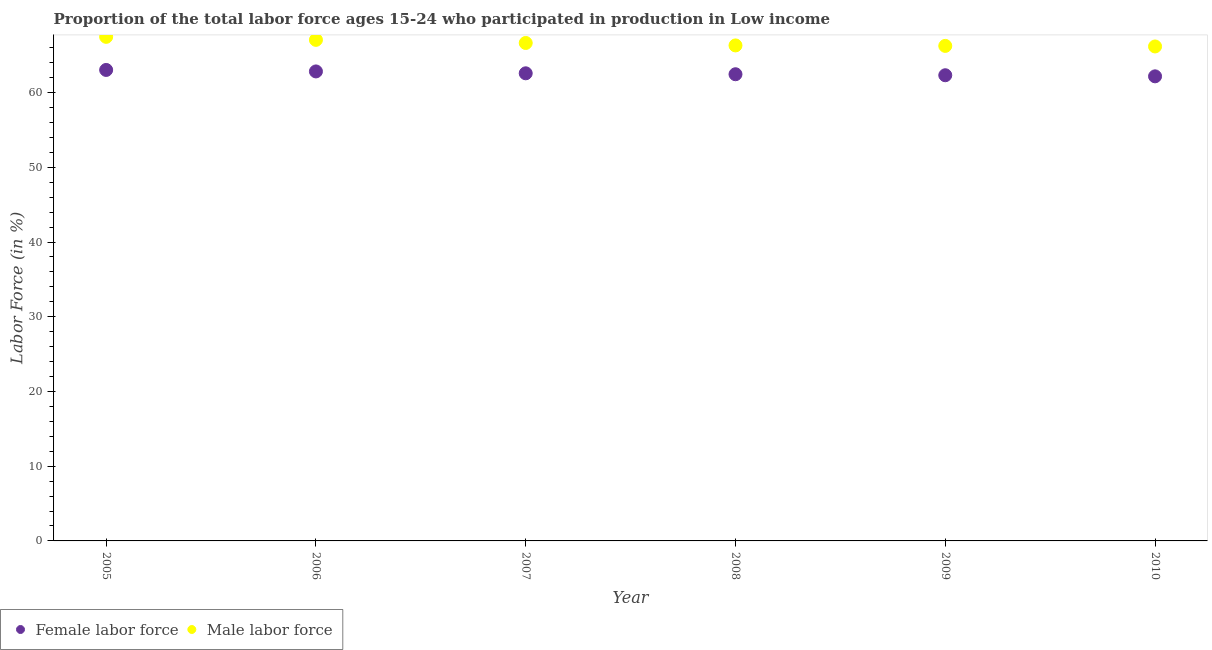Is the number of dotlines equal to the number of legend labels?
Offer a terse response. Yes. What is the percentage of female labor force in 2009?
Ensure brevity in your answer.  62.32. Across all years, what is the maximum percentage of male labour force?
Your response must be concise. 67.46. Across all years, what is the minimum percentage of male labour force?
Your answer should be very brief. 66.18. In which year was the percentage of male labour force maximum?
Offer a terse response. 2005. In which year was the percentage of female labor force minimum?
Give a very brief answer. 2010. What is the total percentage of male labour force in the graph?
Ensure brevity in your answer.  399.91. What is the difference between the percentage of male labour force in 2005 and that in 2006?
Your answer should be very brief. 0.4. What is the difference between the percentage of male labour force in 2007 and the percentage of female labor force in 2006?
Give a very brief answer. 3.81. What is the average percentage of male labour force per year?
Offer a very short reply. 66.65. In the year 2006, what is the difference between the percentage of female labor force and percentage of male labour force?
Keep it short and to the point. -4.22. What is the ratio of the percentage of male labour force in 2006 to that in 2007?
Your answer should be compact. 1.01. Is the percentage of female labor force in 2006 less than that in 2008?
Your answer should be compact. No. Is the difference between the percentage of female labor force in 2006 and 2007 greater than the difference between the percentage of male labour force in 2006 and 2007?
Your answer should be very brief. No. What is the difference between the highest and the second highest percentage of female labor force?
Ensure brevity in your answer.  0.2. What is the difference between the highest and the lowest percentage of female labor force?
Offer a terse response. 0.86. In how many years, is the percentage of female labor force greater than the average percentage of female labor force taken over all years?
Provide a short and direct response. 3. Is the percentage of female labor force strictly greater than the percentage of male labour force over the years?
Your response must be concise. No. How many years are there in the graph?
Provide a succinct answer. 6. Are the values on the major ticks of Y-axis written in scientific E-notation?
Give a very brief answer. No. Does the graph contain any zero values?
Offer a terse response. No. Does the graph contain grids?
Offer a very short reply. No. How many legend labels are there?
Provide a short and direct response. 2. How are the legend labels stacked?
Offer a very short reply. Horizontal. What is the title of the graph?
Keep it short and to the point. Proportion of the total labor force ages 15-24 who participated in production in Low income. Does "Private consumption" appear as one of the legend labels in the graph?
Offer a terse response. No. What is the label or title of the X-axis?
Make the answer very short. Year. What is the label or title of the Y-axis?
Offer a very short reply. Labor Force (in %). What is the Labor Force (in %) in Female labor force in 2005?
Your answer should be very brief. 63.03. What is the Labor Force (in %) of Male labor force in 2005?
Your answer should be very brief. 67.46. What is the Labor Force (in %) of Female labor force in 2006?
Your response must be concise. 62.84. What is the Labor Force (in %) of Male labor force in 2006?
Keep it short and to the point. 67.06. What is the Labor Force (in %) in Female labor force in 2007?
Your answer should be compact. 62.58. What is the Labor Force (in %) in Male labor force in 2007?
Provide a short and direct response. 66.64. What is the Labor Force (in %) in Female labor force in 2008?
Give a very brief answer. 62.46. What is the Labor Force (in %) in Male labor force in 2008?
Keep it short and to the point. 66.32. What is the Labor Force (in %) in Female labor force in 2009?
Make the answer very short. 62.32. What is the Labor Force (in %) in Male labor force in 2009?
Give a very brief answer. 66.25. What is the Labor Force (in %) in Female labor force in 2010?
Your response must be concise. 62.18. What is the Labor Force (in %) of Male labor force in 2010?
Your answer should be very brief. 66.18. Across all years, what is the maximum Labor Force (in %) in Female labor force?
Ensure brevity in your answer.  63.03. Across all years, what is the maximum Labor Force (in %) in Male labor force?
Ensure brevity in your answer.  67.46. Across all years, what is the minimum Labor Force (in %) of Female labor force?
Offer a terse response. 62.18. Across all years, what is the minimum Labor Force (in %) of Male labor force?
Offer a very short reply. 66.18. What is the total Labor Force (in %) in Female labor force in the graph?
Offer a very short reply. 375.41. What is the total Labor Force (in %) in Male labor force in the graph?
Your response must be concise. 399.91. What is the difference between the Labor Force (in %) in Female labor force in 2005 and that in 2006?
Make the answer very short. 0.2. What is the difference between the Labor Force (in %) of Male labor force in 2005 and that in 2006?
Provide a short and direct response. 0.4. What is the difference between the Labor Force (in %) of Female labor force in 2005 and that in 2007?
Your answer should be very brief. 0.45. What is the difference between the Labor Force (in %) in Male labor force in 2005 and that in 2007?
Your answer should be compact. 0.82. What is the difference between the Labor Force (in %) of Female labor force in 2005 and that in 2008?
Provide a short and direct response. 0.58. What is the difference between the Labor Force (in %) of Male labor force in 2005 and that in 2008?
Your answer should be very brief. 1.15. What is the difference between the Labor Force (in %) of Female labor force in 2005 and that in 2009?
Your answer should be very brief. 0.71. What is the difference between the Labor Force (in %) in Male labor force in 2005 and that in 2009?
Your answer should be very brief. 1.21. What is the difference between the Labor Force (in %) in Female labor force in 2005 and that in 2010?
Ensure brevity in your answer.  0.86. What is the difference between the Labor Force (in %) of Female labor force in 2006 and that in 2007?
Your answer should be compact. 0.25. What is the difference between the Labor Force (in %) in Male labor force in 2006 and that in 2007?
Make the answer very short. 0.42. What is the difference between the Labor Force (in %) of Female labor force in 2006 and that in 2008?
Your answer should be very brief. 0.38. What is the difference between the Labor Force (in %) of Male labor force in 2006 and that in 2008?
Give a very brief answer. 0.74. What is the difference between the Labor Force (in %) of Female labor force in 2006 and that in 2009?
Give a very brief answer. 0.51. What is the difference between the Labor Force (in %) in Male labor force in 2006 and that in 2009?
Your answer should be compact. 0.81. What is the difference between the Labor Force (in %) in Female labor force in 2006 and that in 2010?
Your answer should be compact. 0.66. What is the difference between the Labor Force (in %) of Male labor force in 2006 and that in 2010?
Provide a short and direct response. 0.88. What is the difference between the Labor Force (in %) of Female labor force in 2007 and that in 2008?
Make the answer very short. 0.12. What is the difference between the Labor Force (in %) in Male labor force in 2007 and that in 2008?
Ensure brevity in your answer.  0.33. What is the difference between the Labor Force (in %) in Female labor force in 2007 and that in 2009?
Offer a very short reply. 0.26. What is the difference between the Labor Force (in %) in Male labor force in 2007 and that in 2009?
Your answer should be compact. 0.39. What is the difference between the Labor Force (in %) in Female labor force in 2007 and that in 2010?
Your answer should be very brief. 0.4. What is the difference between the Labor Force (in %) in Male labor force in 2007 and that in 2010?
Provide a succinct answer. 0.47. What is the difference between the Labor Force (in %) of Female labor force in 2008 and that in 2009?
Offer a very short reply. 0.13. What is the difference between the Labor Force (in %) in Male labor force in 2008 and that in 2009?
Offer a very short reply. 0.06. What is the difference between the Labor Force (in %) of Female labor force in 2008 and that in 2010?
Your response must be concise. 0.28. What is the difference between the Labor Force (in %) of Male labor force in 2008 and that in 2010?
Make the answer very short. 0.14. What is the difference between the Labor Force (in %) in Female labor force in 2009 and that in 2010?
Provide a short and direct response. 0.15. What is the difference between the Labor Force (in %) in Male labor force in 2009 and that in 2010?
Provide a short and direct response. 0.08. What is the difference between the Labor Force (in %) in Female labor force in 2005 and the Labor Force (in %) in Male labor force in 2006?
Offer a terse response. -4.02. What is the difference between the Labor Force (in %) of Female labor force in 2005 and the Labor Force (in %) of Male labor force in 2007?
Provide a succinct answer. -3.61. What is the difference between the Labor Force (in %) of Female labor force in 2005 and the Labor Force (in %) of Male labor force in 2008?
Offer a terse response. -3.28. What is the difference between the Labor Force (in %) in Female labor force in 2005 and the Labor Force (in %) in Male labor force in 2009?
Your response must be concise. -3.22. What is the difference between the Labor Force (in %) of Female labor force in 2005 and the Labor Force (in %) of Male labor force in 2010?
Make the answer very short. -3.14. What is the difference between the Labor Force (in %) in Female labor force in 2006 and the Labor Force (in %) in Male labor force in 2007?
Offer a terse response. -3.81. What is the difference between the Labor Force (in %) of Female labor force in 2006 and the Labor Force (in %) of Male labor force in 2008?
Your answer should be compact. -3.48. What is the difference between the Labor Force (in %) of Female labor force in 2006 and the Labor Force (in %) of Male labor force in 2009?
Make the answer very short. -3.42. What is the difference between the Labor Force (in %) of Female labor force in 2006 and the Labor Force (in %) of Male labor force in 2010?
Your answer should be compact. -3.34. What is the difference between the Labor Force (in %) of Female labor force in 2007 and the Labor Force (in %) of Male labor force in 2008?
Keep it short and to the point. -3.73. What is the difference between the Labor Force (in %) in Female labor force in 2007 and the Labor Force (in %) in Male labor force in 2009?
Your answer should be very brief. -3.67. What is the difference between the Labor Force (in %) of Female labor force in 2007 and the Labor Force (in %) of Male labor force in 2010?
Your answer should be very brief. -3.59. What is the difference between the Labor Force (in %) of Female labor force in 2008 and the Labor Force (in %) of Male labor force in 2009?
Provide a short and direct response. -3.79. What is the difference between the Labor Force (in %) in Female labor force in 2008 and the Labor Force (in %) in Male labor force in 2010?
Your response must be concise. -3.72. What is the difference between the Labor Force (in %) of Female labor force in 2009 and the Labor Force (in %) of Male labor force in 2010?
Provide a succinct answer. -3.85. What is the average Labor Force (in %) in Female labor force per year?
Offer a terse response. 62.57. What is the average Labor Force (in %) in Male labor force per year?
Offer a very short reply. 66.65. In the year 2005, what is the difference between the Labor Force (in %) in Female labor force and Labor Force (in %) in Male labor force?
Your answer should be compact. -4.43. In the year 2006, what is the difference between the Labor Force (in %) of Female labor force and Labor Force (in %) of Male labor force?
Offer a very short reply. -4.22. In the year 2007, what is the difference between the Labor Force (in %) in Female labor force and Labor Force (in %) in Male labor force?
Make the answer very short. -4.06. In the year 2008, what is the difference between the Labor Force (in %) in Female labor force and Labor Force (in %) in Male labor force?
Your response must be concise. -3.86. In the year 2009, what is the difference between the Labor Force (in %) of Female labor force and Labor Force (in %) of Male labor force?
Your answer should be very brief. -3.93. In the year 2010, what is the difference between the Labor Force (in %) in Female labor force and Labor Force (in %) in Male labor force?
Keep it short and to the point. -4. What is the ratio of the Labor Force (in %) of Female labor force in 2005 to that in 2006?
Ensure brevity in your answer.  1. What is the ratio of the Labor Force (in %) of Male labor force in 2005 to that in 2006?
Offer a terse response. 1.01. What is the ratio of the Labor Force (in %) of Female labor force in 2005 to that in 2007?
Your answer should be very brief. 1.01. What is the ratio of the Labor Force (in %) in Male labor force in 2005 to that in 2007?
Give a very brief answer. 1.01. What is the ratio of the Labor Force (in %) in Female labor force in 2005 to that in 2008?
Your answer should be compact. 1.01. What is the ratio of the Labor Force (in %) in Male labor force in 2005 to that in 2008?
Provide a succinct answer. 1.02. What is the ratio of the Labor Force (in %) in Female labor force in 2005 to that in 2009?
Give a very brief answer. 1.01. What is the ratio of the Labor Force (in %) in Male labor force in 2005 to that in 2009?
Make the answer very short. 1.02. What is the ratio of the Labor Force (in %) in Female labor force in 2005 to that in 2010?
Offer a terse response. 1.01. What is the ratio of the Labor Force (in %) in Male labor force in 2005 to that in 2010?
Ensure brevity in your answer.  1.02. What is the ratio of the Labor Force (in %) in Female labor force in 2006 to that in 2007?
Offer a terse response. 1. What is the ratio of the Labor Force (in %) of Male labor force in 2006 to that in 2007?
Your answer should be compact. 1.01. What is the ratio of the Labor Force (in %) of Female labor force in 2006 to that in 2008?
Provide a short and direct response. 1.01. What is the ratio of the Labor Force (in %) in Male labor force in 2006 to that in 2008?
Your answer should be very brief. 1.01. What is the ratio of the Labor Force (in %) of Female labor force in 2006 to that in 2009?
Ensure brevity in your answer.  1.01. What is the ratio of the Labor Force (in %) of Male labor force in 2006 to that in 2009?
Keep it short and to the point. 1.01. What is the ratio of the Labor Force (in %) in Female labor force in 2006 to that in 2010?
Give a very brief answer. 1.01. What is the ratio of the Labor Force (in %) in Male labor force in 2006 to that in 2010?
Provide a short and direct response. 1.01. What is the ratio of the Labor Force (in %) of Male labor force in 2007 to that in 2008?
Provide a short and direct response. 1. What is the ratio of the Labor Force (in %) of Male labor force in 2007 to that in 2009?
Give a very brief answer. 1.01. What is the ratio of the Labor Force (in %) of Male labor force in 2007 to that in 2010?
Your answer should be very brief. 1.01. What is the ratio of the Labor Force (in %) of Female labor force in 2008 to that in 2009?
Ensure brevity in your answer.  1. What is the ratio of the Labor Force (in %) of Male labor force in 2008 to that in 2009?
Provide a short and direct response. 1. What is the ratio of the Labor Force (in %) of Female labor force in 2008 to that in 2010?
Ensure brevity in your answer.  1. What is the ratio of the Labor Force (in %) in Male labor force in 2008 to that in 2010?
Make the answer very short. 1. What is the ratio of the Labor Force (in %) in Female labor force in 2009 to that in 2010?
Offer a terse response. 1. What is the difference between the highest and the second highest Labor Force (in %) of Female labor force?
Offer a very short reply. 0.2. What is the difference between the highest and the second highest Labor Force (in %) in Male labor force?
Offer a very short reply. 0.4. What is the difference between the highest and the lowest Labor Force (in %) of Female labor force?
Provide a short and direct response. 0.86. What is the difference between the highest and the lowest Labor Force (in %) in Male labor force?
Offer a very short reply. 1.29. 